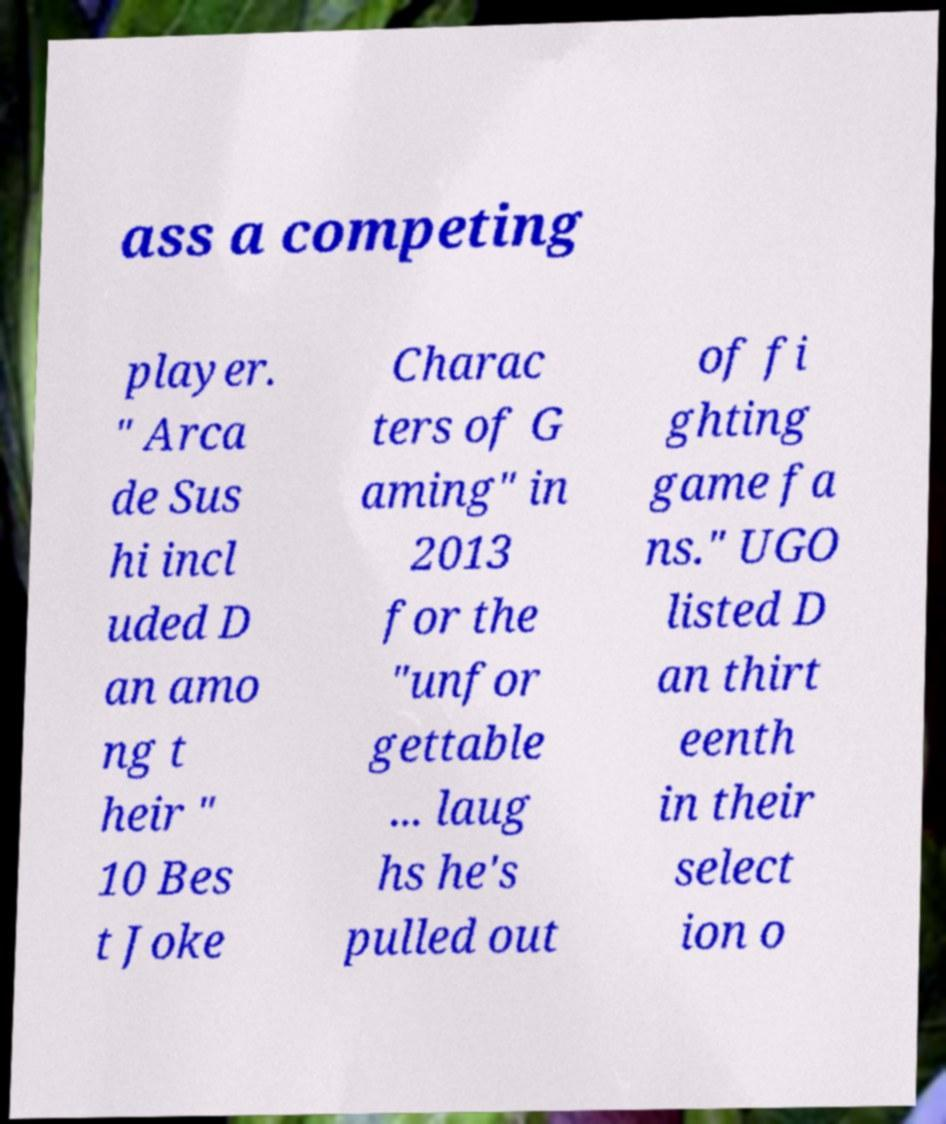There's text embedded in this image that I need extracted. Can you transcribe it verbatim? ass a competing player. " Arca de Sus hi incl uded D an amo ng t heir " 10 Bes t Joke Charac ters of G aming" in 2013 for the "unfor gettable ... laug hs he's pulled out of fi ghting game fa ns." UGO listed D an thirt eenth in their select ion o 